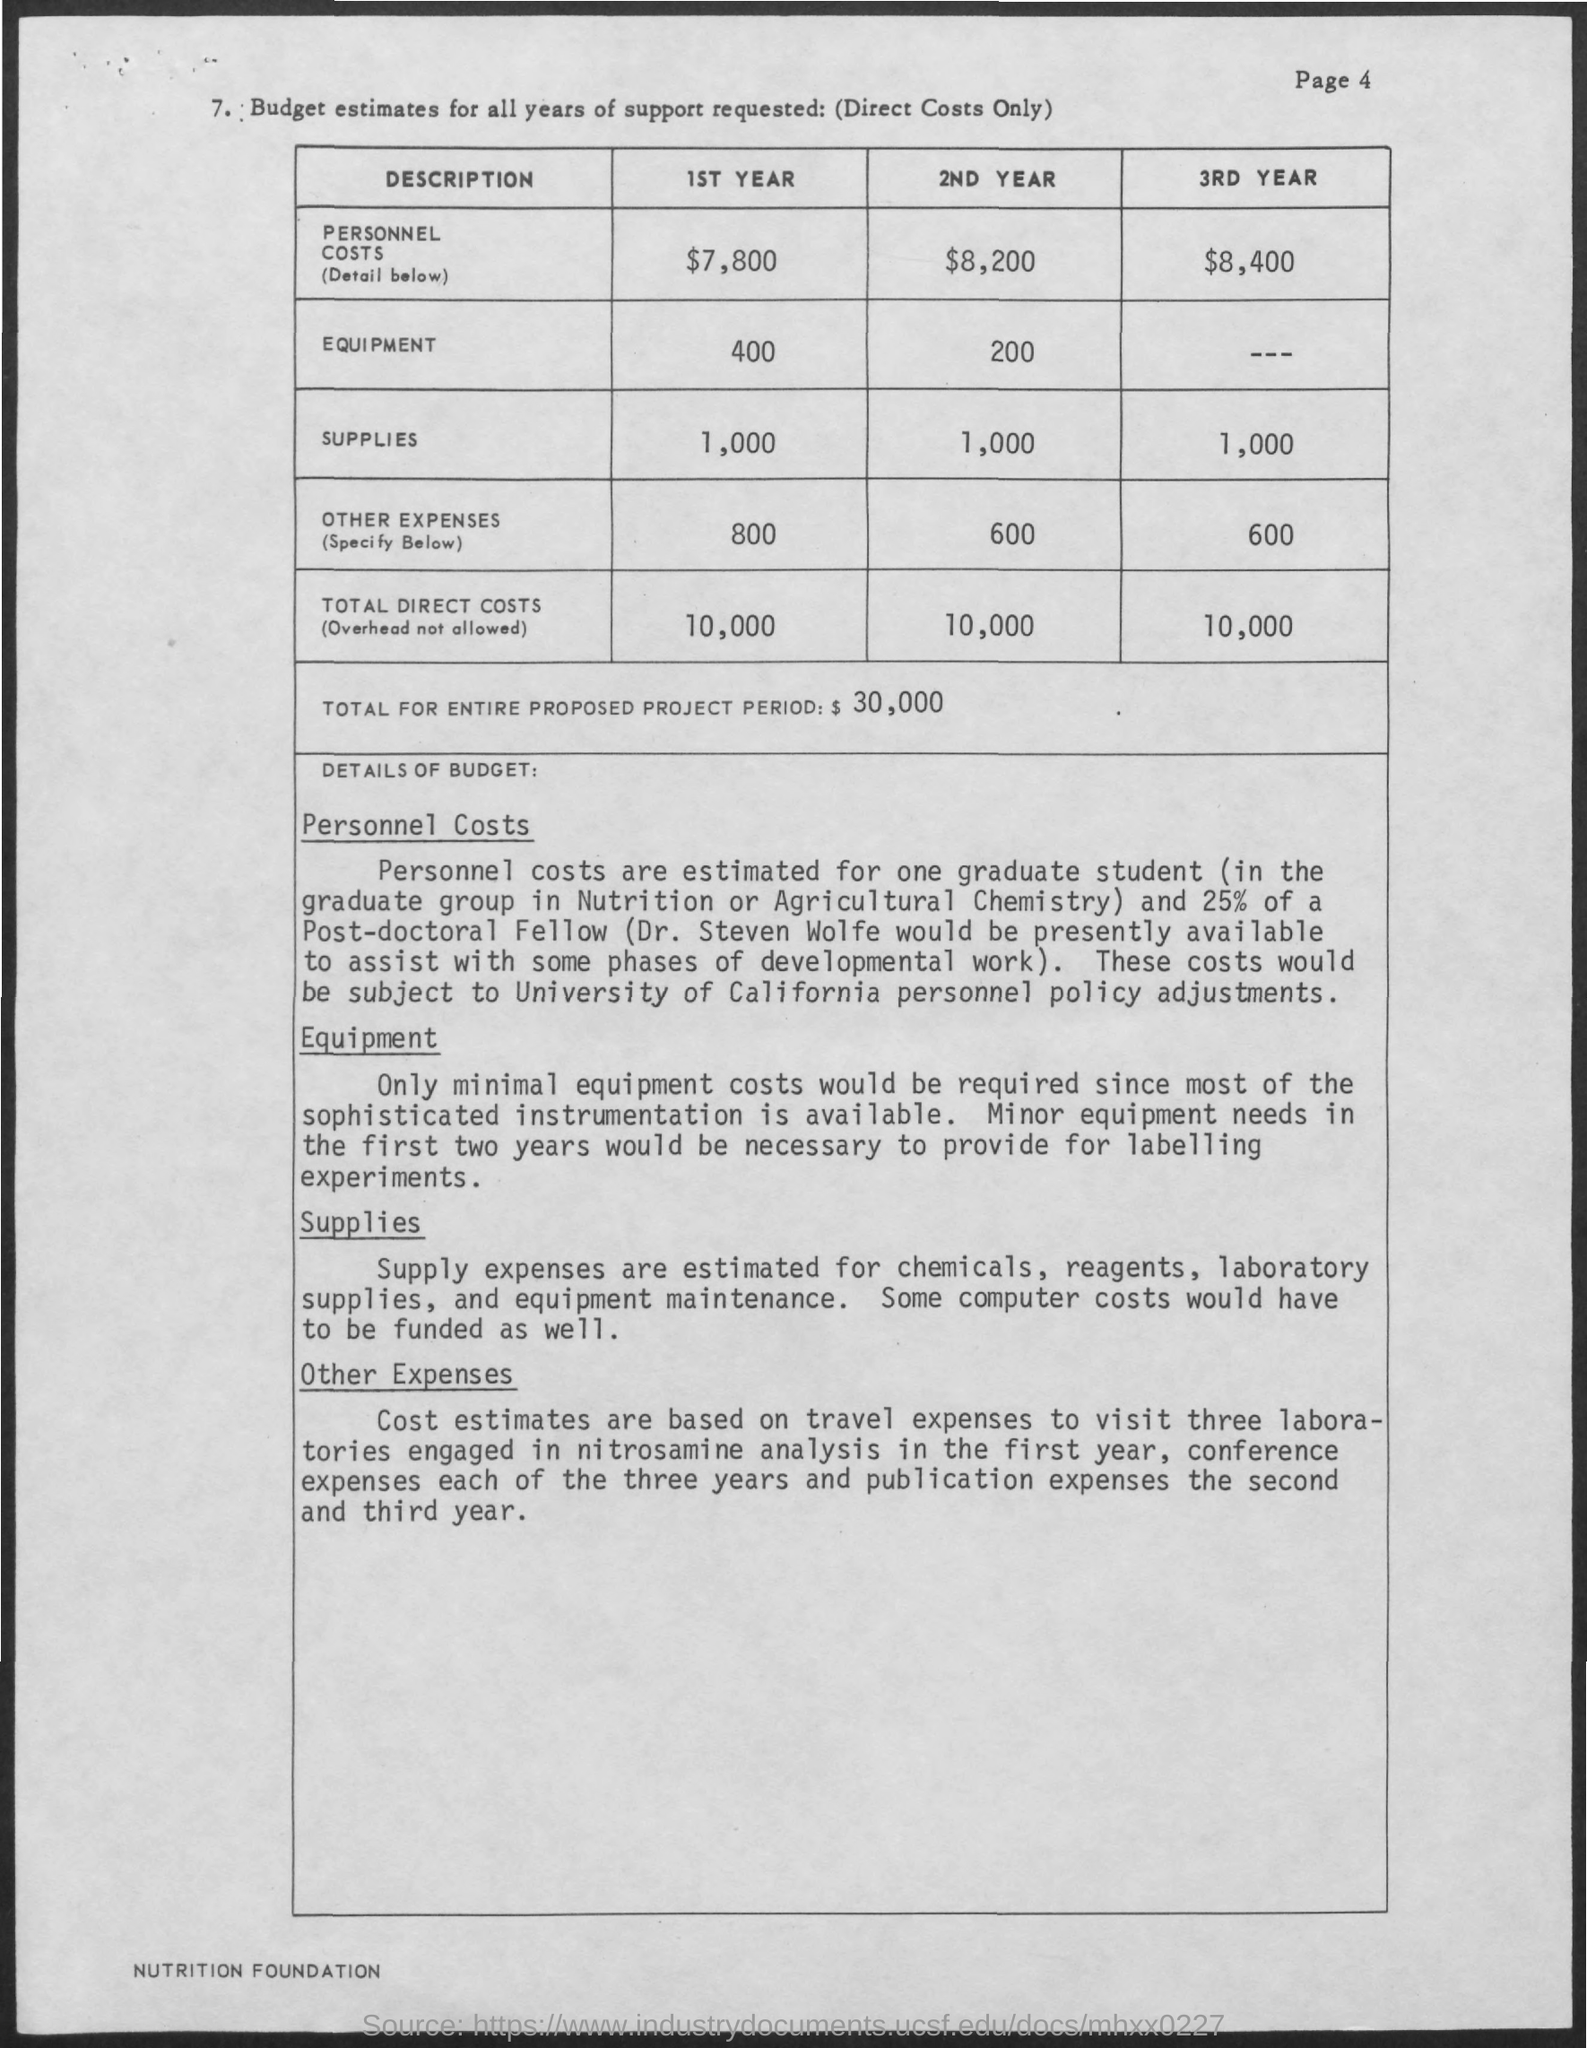What are the personnel Costs for 1st Year?
Your answer should be compact. $7,800. What are the personnel Costs for 2nd Year?
Provide a succinct answer. $8,200. What are the personnel Costs for 3RD Year?
Offer a very short reply. $8,400. What are the Equipment Costs for 1st Year?
Give a very brief answer. 400. What are the Equipment Costs for 2ND Year?
Offer a very short reply. 200. What are the Supplies Costs for 1st Year?
Provide a succinct answer. 1,000. What are the Supplies Costs for 2ND Year?
Provide a short and direct response. 1,000. What are the Supplies Costs for 3RD Year?
Keep it short and to the point. $1,000. What are the Total Direct Costs for 1st Year?
Provide a short and direct response. 10,000. What are the Total Direct Costs for 2ND Year?
Offer a terse response. 10,000. 